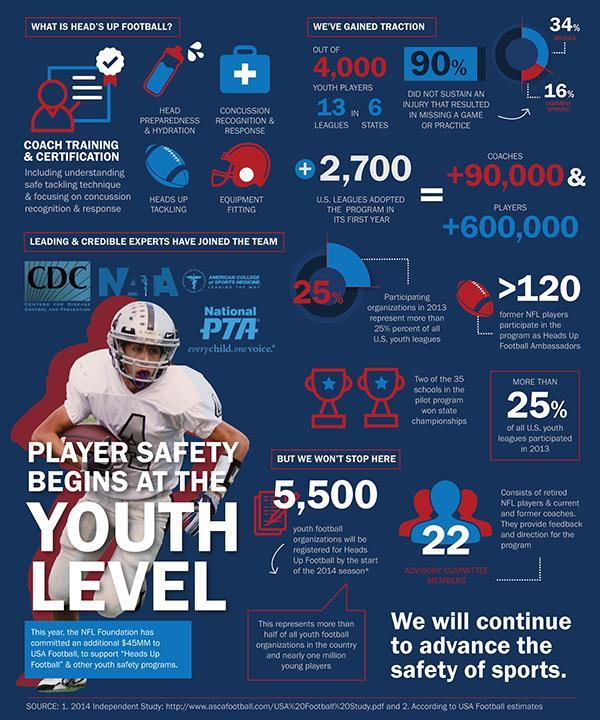How many youth football organisations will be registered for Heads Up Football by the start of the 2014 season?
Answer the question with a short phrase. 5,500 What is the number of members in advisory committee of Heads Up Football? 22 How many U.S. leagues adopted the 'Heads-Up Football' & other safety programs in its first year? +2,700 